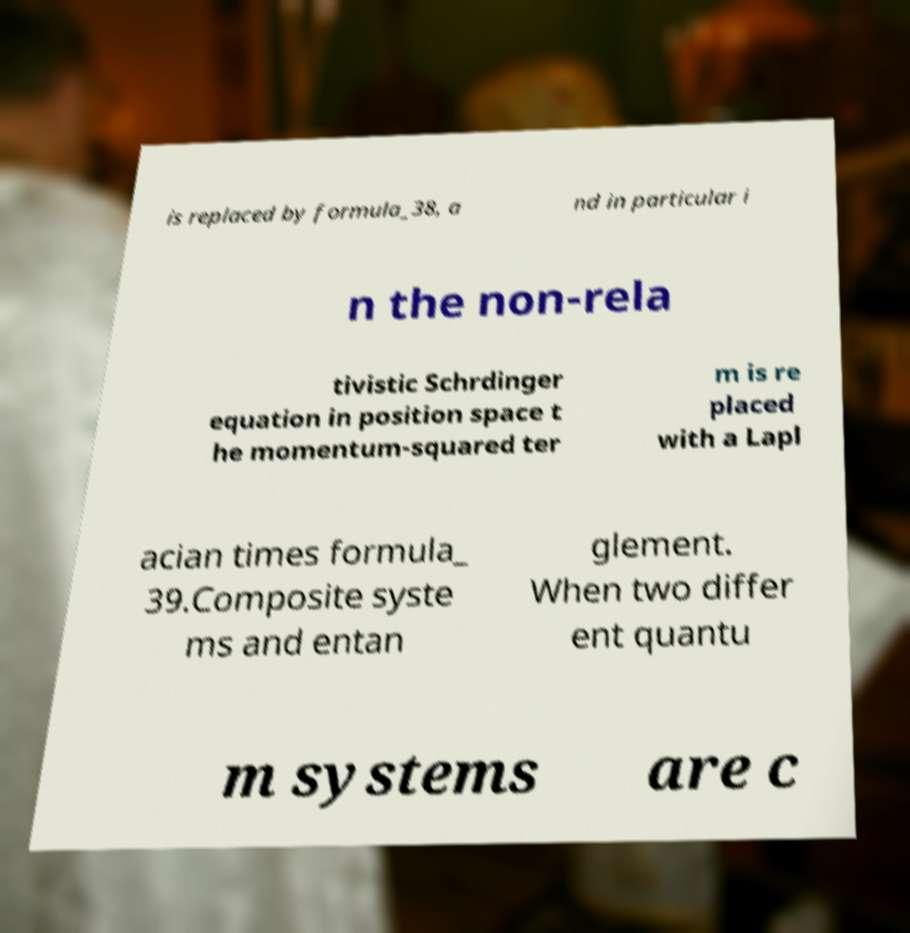Could you extract and type out the text from this image? is replaced by formula_38, a nd in particular i n the non-rela tivistic Schrdinger equation in position space t he momentum-squared ter m is re placed with a Lapl acian times formula_ 39.Composite syste ms and entan glement. When two differ ent quantu m systems are c 